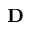<formula> <loc_0><loc_0><loc_500><loc_500>D</formula> 